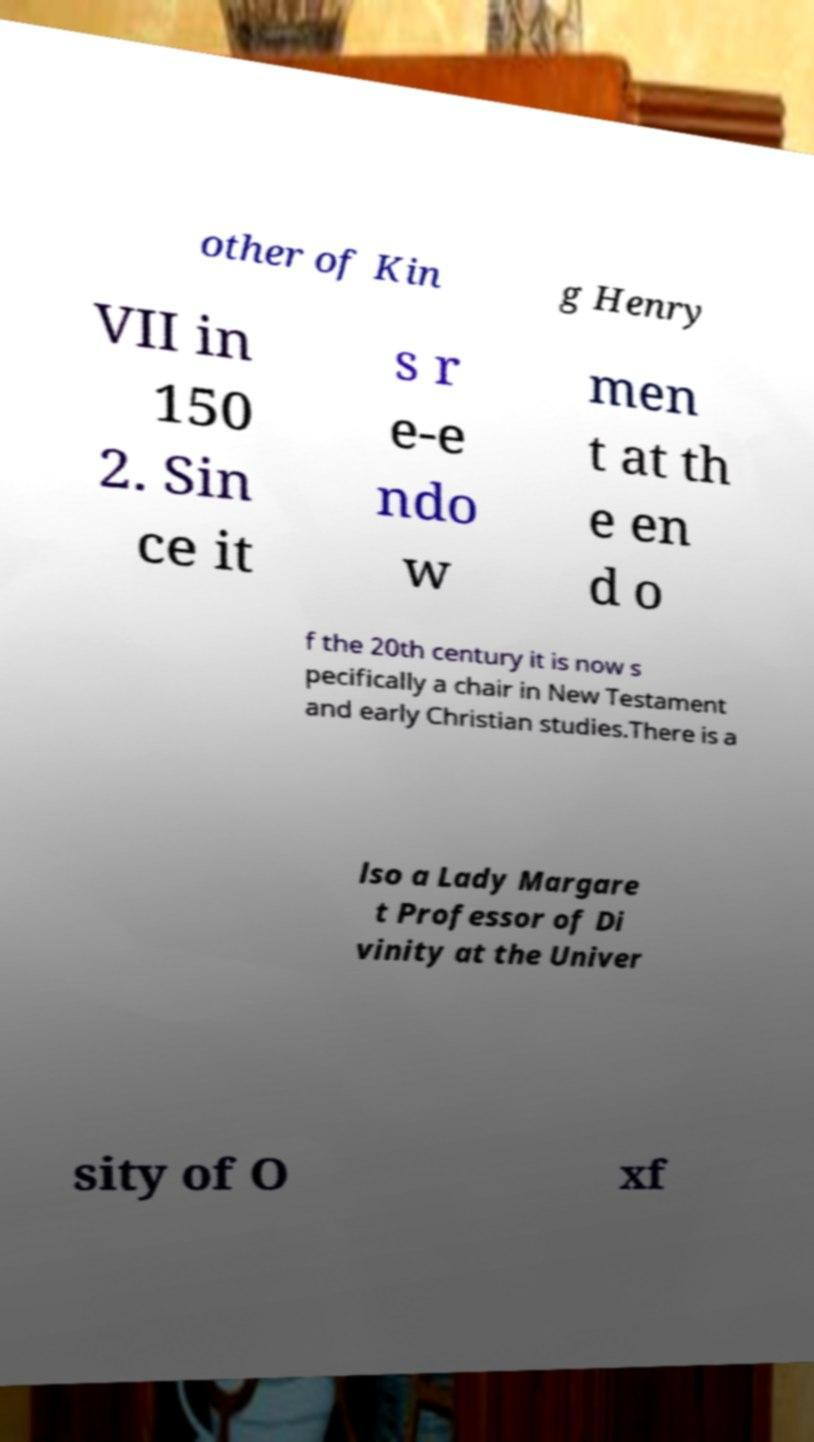What messages or text are displayed in this image? I need them in a readable, typed format. other of Kin g Henry VII in 150 2. Sin ce it s r e-e ndo w men t at th e en d o f the 20th century it is now s pecifically a chair in New Testament and early Christian studies.There is a lso a Lady Margare t Professor of Di vinity at the Univer sity of O xf 